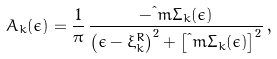Convert formula to latex. <formula><loc_0><loc_0><loc_500><loc_500>A _ { k } ( \epsilon ) = \frac { 1 } { \pi } \, \frac { - \i m \Sigma _ { k } ( \epsilon ) } { \left ( \epsilon - \xi _ { k } ^ { R } \right ) ^ { 2 } + \left [ \i m \Sigma _ { k } ( \epsilon ) \right ] ^ { 2 } } \, ,</formula> 